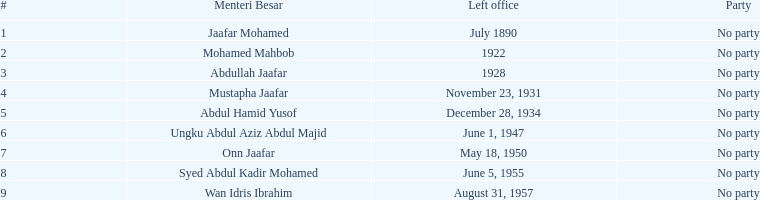Parse the table in full. {'header': ['#', 'Menteri Besar', 'Left office', 'Party'], 'rows': [['1', 'Jaafar Mohamed', 'July 1890', 'No party'], ['2', 'Mohamed Mahbob', '1922', 'No party'], ['3', 'Abdullah Jaafar', '1928', 'No party'], ['4', 'Mustapha Jaafar', 'November 23, 1931', 'No party'], ['5', 'Abdul Hamid Yusof', 'December 28, 1934', 'No party'], ['6', 'Ungku Abdul Aziz Abdul Majid', 'June 1, 1947', 'No party'], ['7', 'Onn Jaafar', 'May 18, 1950', 'No party'], ['8', 'Syed Abdul Kadir Mohamed', 'June 5, 1955', 'No party'], ['9', 'Wan Idris Ibrahim', 'August 31, 1957', 'No party']]} What is the quantity of menteri besar who served for 4 or more years? 3. 